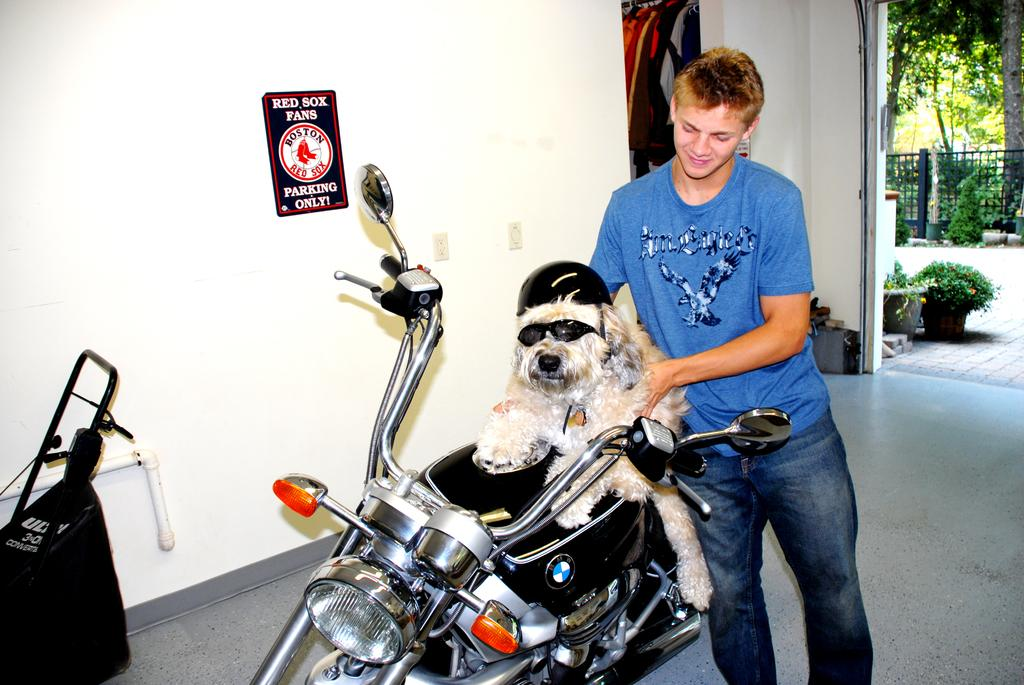Who is present in the image? There is a man in the image. What is the man holding? The man is holding a dog. What mode of transportation are the man and dog using? The man and dog are on a motorcycle. What can be seen on the wall in the image? There is a poster on a wall in the image. What type of vegetation is visible in the image? There are plants and trees visible in the image. What type of meal is being prepared for the dog in the image? There is no indication in the image that a meal is being prepared for the dog. 